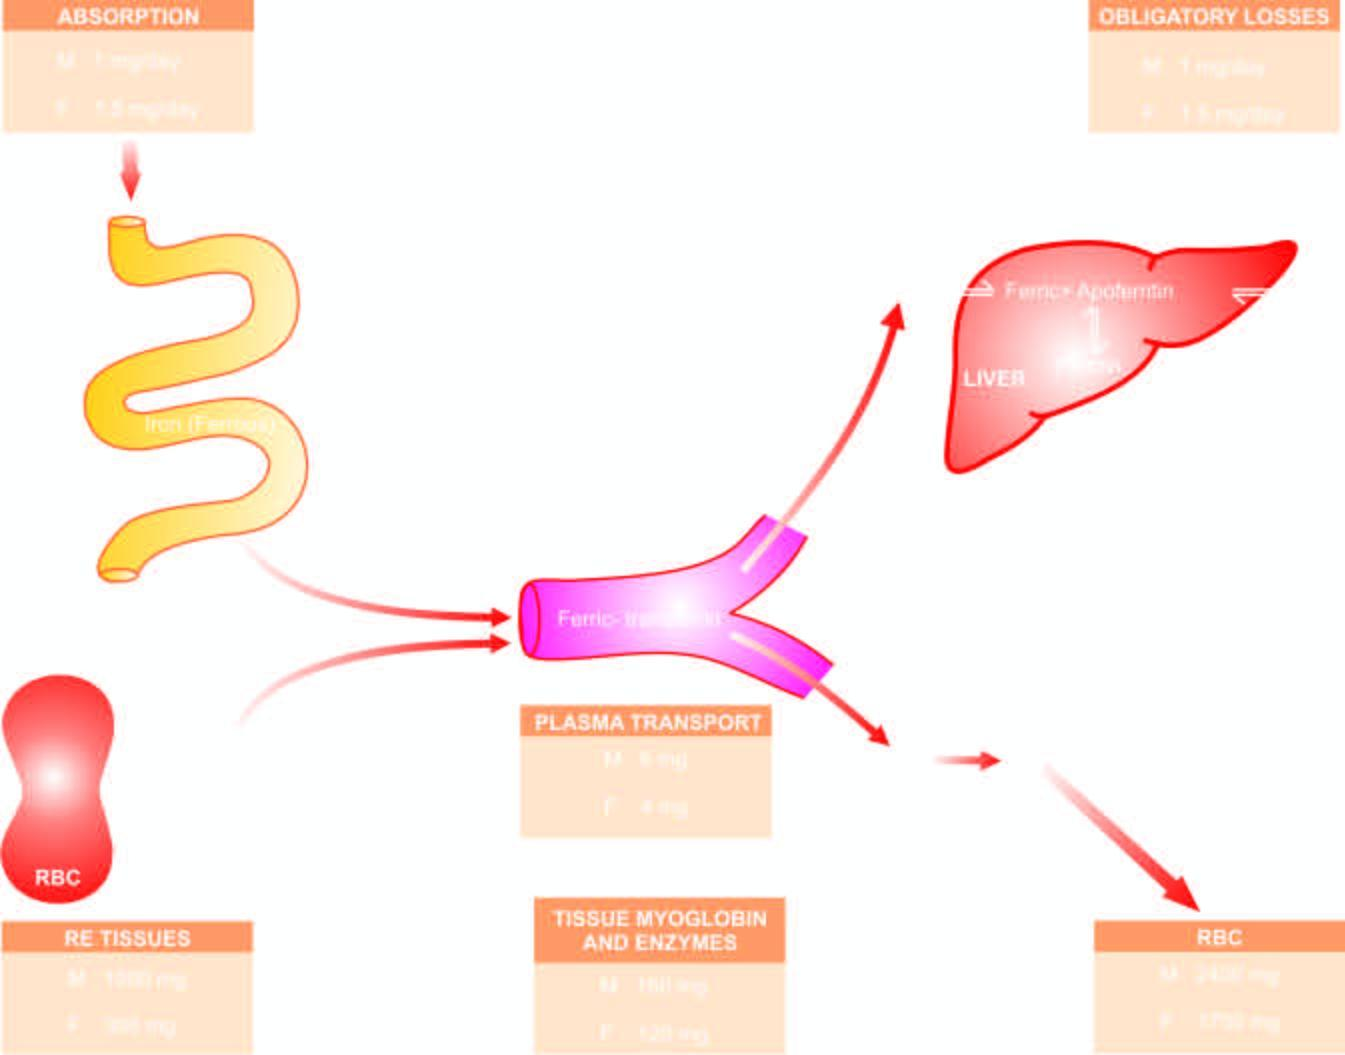re the mature red cells released into circulation, which on completion of their lifespan of 120 days, die?
Answer the question using a single word or phrase. Yes 